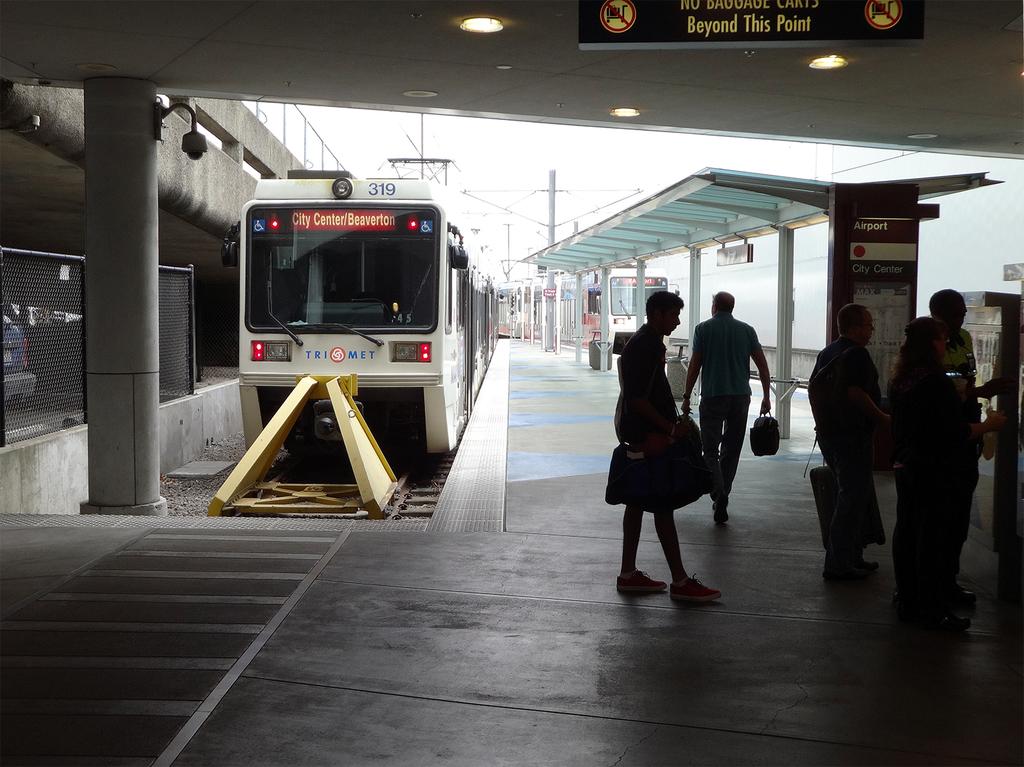What is the number of this subway?
Provide a succinct answer. 319. 